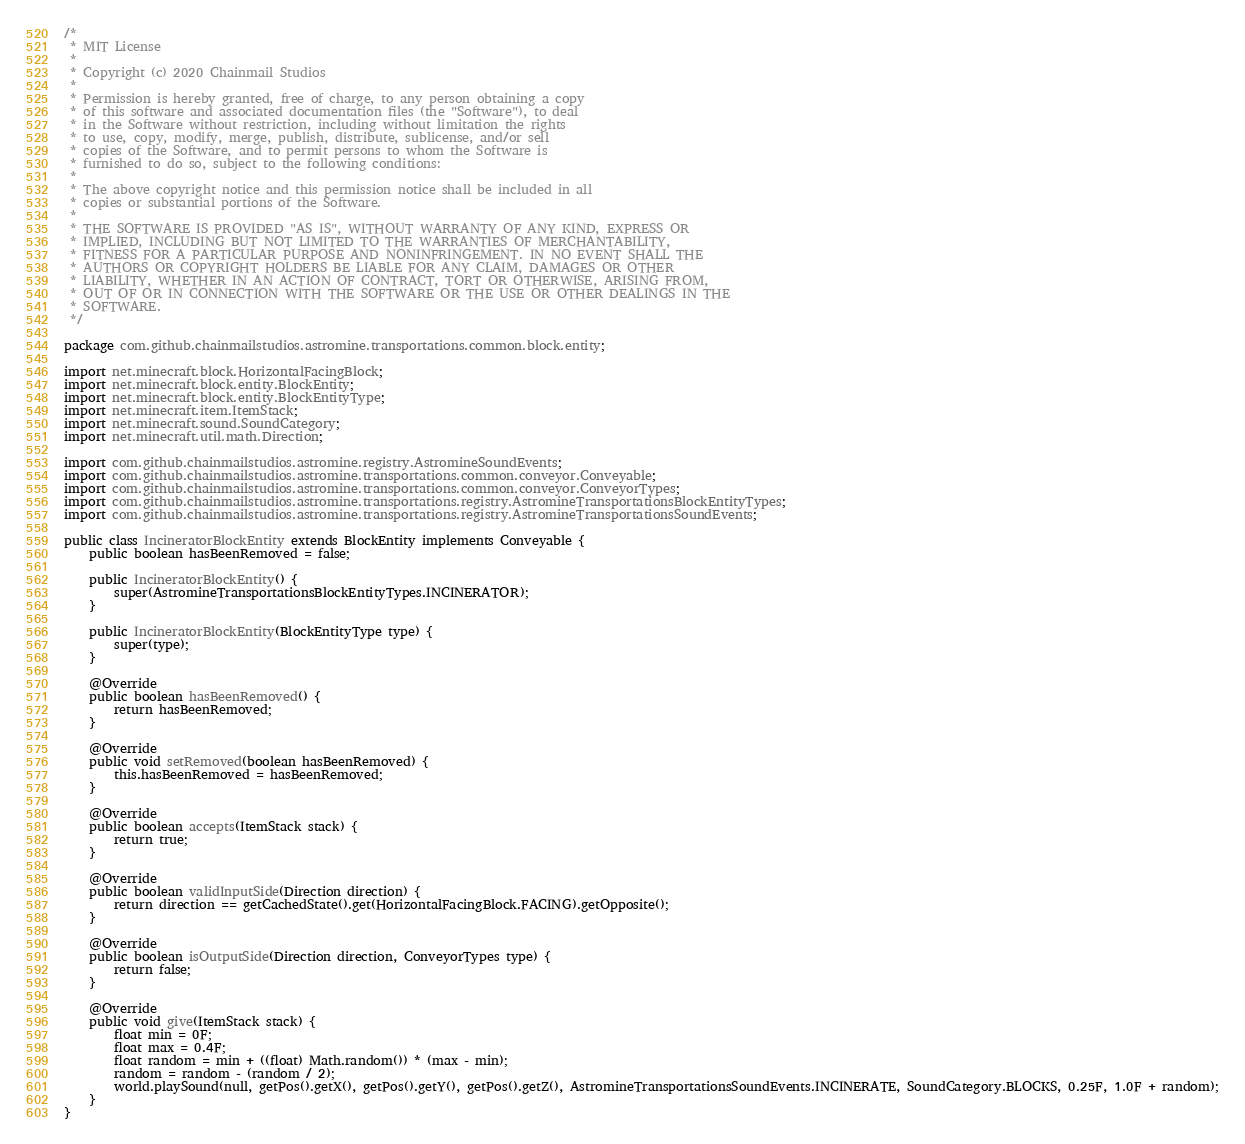<code> <loc_0><loc_0><loc_500><loc_500><_Java_>/*
 * MIT License
 *
 * Copyright (c) 2020 Chainmail Studios
 *
 * Permission is hereby granted, free of charge, to any person obtaining a copy
 * of this software and associated documentation files (the "Software"), to deal
 * in the Software without restriction, including without limitation the rights
 * to use, copy, modify, merge, publish, distribute, sublicense, and/or sell
 * copies of the Software, and to permit persons to whom the Software is
 * furnished to do so, subject to the following conditions:
 *
 * The above copyright notice and this permission notice shall be included in all
 * copies or substantial portions of the Software.
 *
 * THE SOFTWARE IS PROVIDED "AS IS", WITHOUT WARRANTY OF ANY KIND, EXPRESS OR
 * IMPLIED, INCLUDING BUT NOT LIMITED TO THE WARRANTIES OF MERCHANTABILITY,
 * FITNESS FOR A PARTICULAR PURPOSE AND NONINFRINGEMENT. IN NO EVENT SHALL THE
 * AUTHORS OR COPYRIGHT HOLDERS BE LIABLE FOR ANY CLAIM, DAMAGES OR OTHER
 * LIABILITY, WHETHER IN AN ACTION OF CONTRACT, TORT OR OTHERWISE, ARISING FROM,
 * OUT OF OR IN CONNECTION WITH THE SOFTWARE OR THE USE OR OTHER DEALINGS IN THE
 * SOFTWARE.
 */

package com.github.chainmailstudios.astromine.transportations.common.block.entity;

import net.minecraft.block.HorizontalFacingBlock;
import net.minecraft.block.entity.BlockEntity;
import net.minecraft.block.entity.BlockEntityType;
import net.minecraft.item.ItemStack;
import net.minecraft.sound.SoundCategory;
import net.minecraft.util.math.Direction;

import com.github.chainmailstudios.astromine.registry.AstromineSoundEvents;
import com.github.chainmailstudios.astromine.transportations.common.conveyor.Conveyable;
import com.github.chainmailstudios.astromine.transportations.common.conveyor.ConveyorTypes;
import com.github.chainmailstudios.astromine.transportations.registry.AstromineTransportationsBlockEntityTypes;
import com.github.chainmailstudios.astromine.transportations.registry.AstromineTransportationsSoundEvents;

public class IncineratorBlockEntity extends BlockEntity implements Conveyable {
	public boolean hasBeenRemoved = false;

	public IncineratorBlockEntity() {
		super(AstromineTransportationsBlockEntityTypes.INCINERATOR);
	}

	public IncineratorBlockEntity(BlockEntityType type) {
		super(type);
	}

	@Override
	public boolean hasBeenRemoved() {
		return hasBeenRemoved;
	}

	@Override
	public void setRemoved(boolean hasBeenRemoved) {
		this.hasBeenRemoved = hasBeenRemoved;
	}

	@Override
	public boolean accepts(ItemStack stack) {
		return true;
	}

	@Override
	public boolean validInputSide(Direction direction) {
		return direction == getCachedState().get(HorizontalFacingBlock.FACING).getOpposite();
	}

	@Override
	public boolean isOutputSide(Direction direction, ConveyorTypes type) {
		return false;
	}

	@Override
	public void give(ItemStack stack) {
		float min = 0F;
		float max = 0.4F;
		float random = min + ((float) Math.random()) * (max - min);
		random = random - (random / 2);
		world.playSound(null, getPos().getX(), getPos().getY(), getPos().getZ(), AstromineTransportationsSoundEvents.INCINERATE, SoundCategory.BLOCKS, 0.25F, 1.0F + random);
	}
}
</code> 